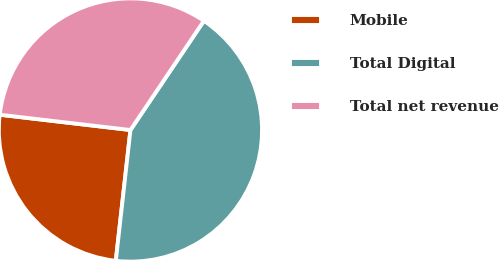<chart> <loc_0><loc_0><loc_500><loc_500><pie_chart><fcel>Mobile<fcel>Total Digital<fcel>Total net revenue<nl><fcel>25.08%<fcel>42.35%<fcel>32.57%<nl></chart> 